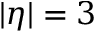Convert formula to latex. <formula><loc_0><loc_0><loc_500><loc_500>| \eta | = 3</formula> 